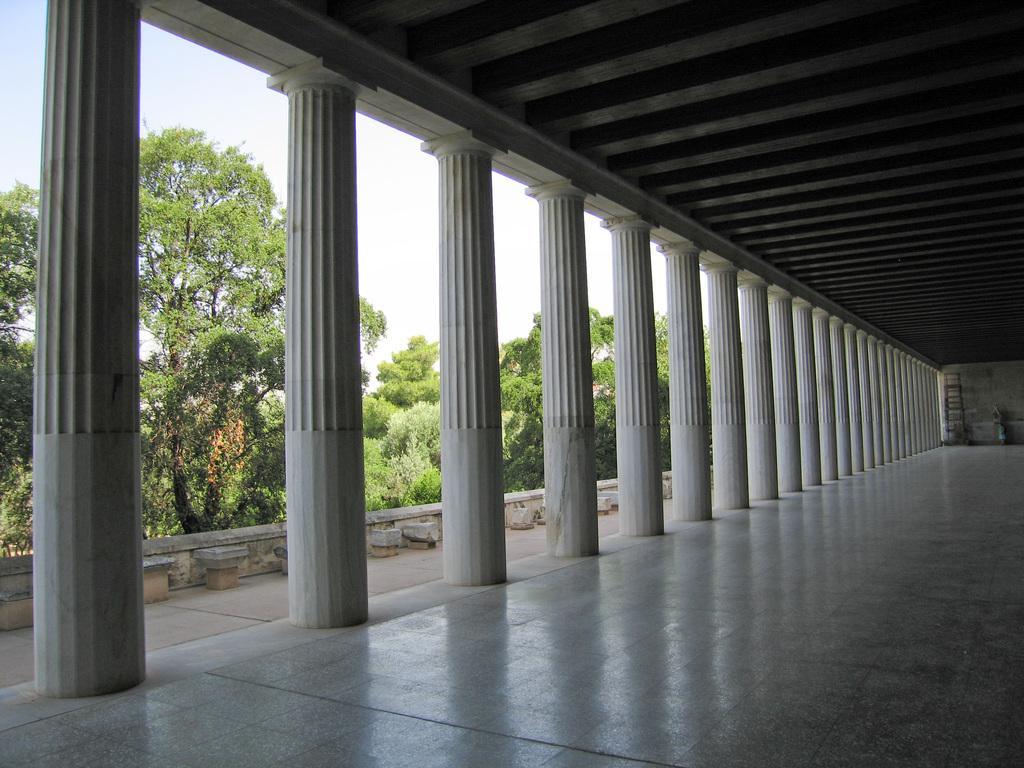In one or two sentences, can you explain what this image depicts? In this image we can see the shed and the pillars. We can see the trees and the sky. 